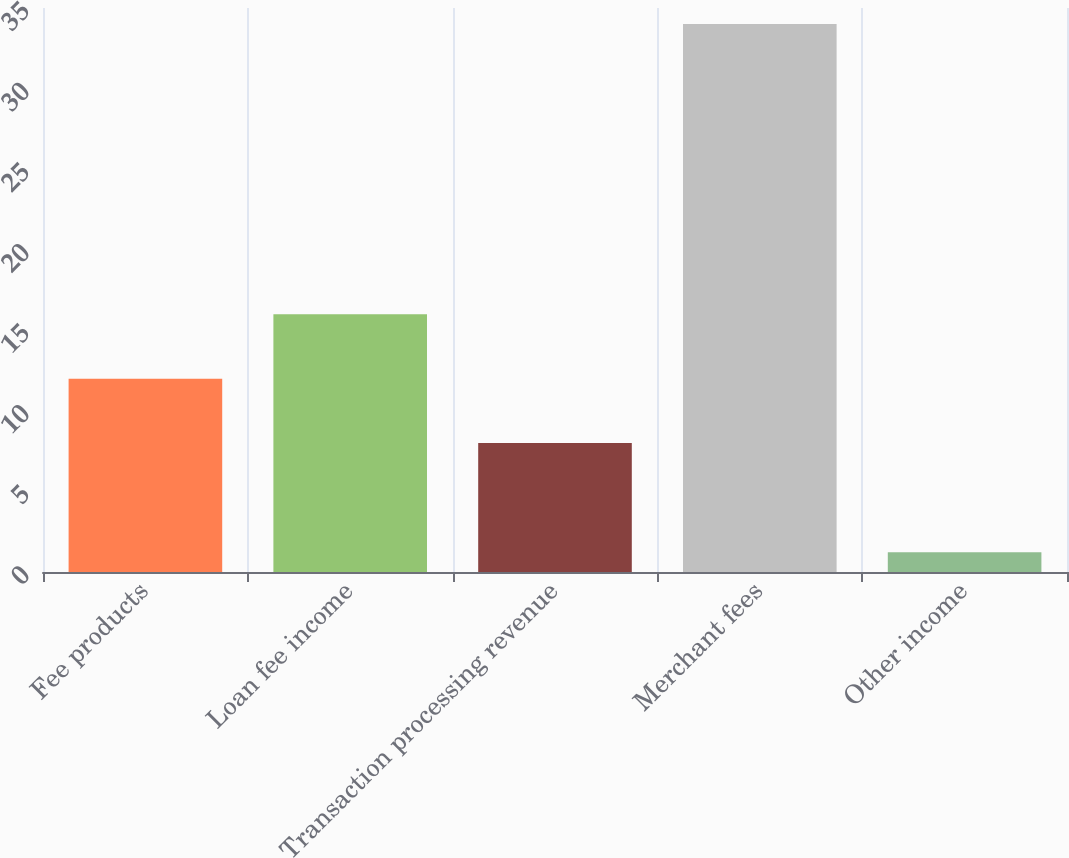Convert chart to OTSL. <chart><loc_0><loc_0><loc_500><loc_500><bar_chart><fcel>Fee products<fcel>Loan fee income<fcel>Transaction processing revenue<fcel>Merchant fees<fcel>Other income<nl><fcel>12<fcel>16<fcel>8<fcel>34<fcel>1.22<nl></chart> 